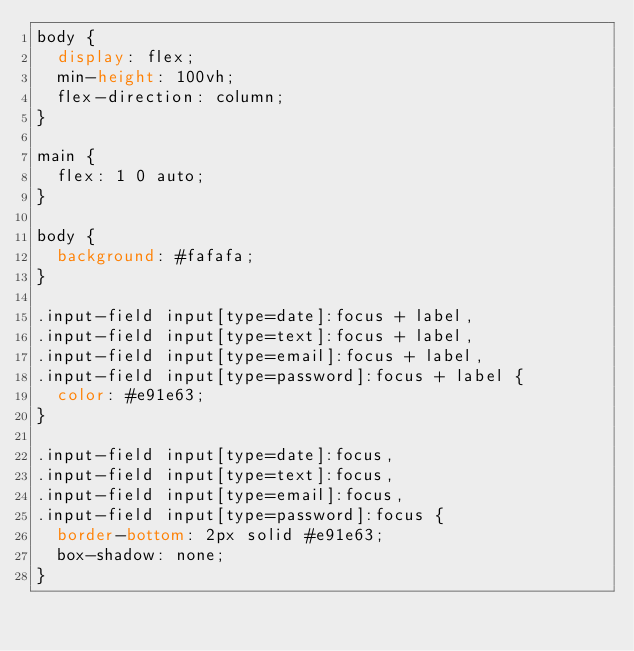Convert code to text. <code><loc_0><loc_0><loc_500><loc_500><_CSS_>body {
  display: flex;
  min-height: 100vh;
  flex-direction: column;
}

main {
  flex: 1 0 auto;
}

body {
  background: #fafafa;
}

.input-field input[type=date]:focus + label,
.input-field input[type=text]:focus + label,
.input-field input[type=email]:focus + label,
.input-field input[type=password]:focus + label {
  color: #e91e63;
}

.input-field input[type=date]:focus,
.input-field input[type=text]:focus,
.input-field input[type=email]:focus,
.input-field input[type=password]:focus {
  border-bottom: 2px solid #e91e63;
  box-shadow: none;
}
</code> 